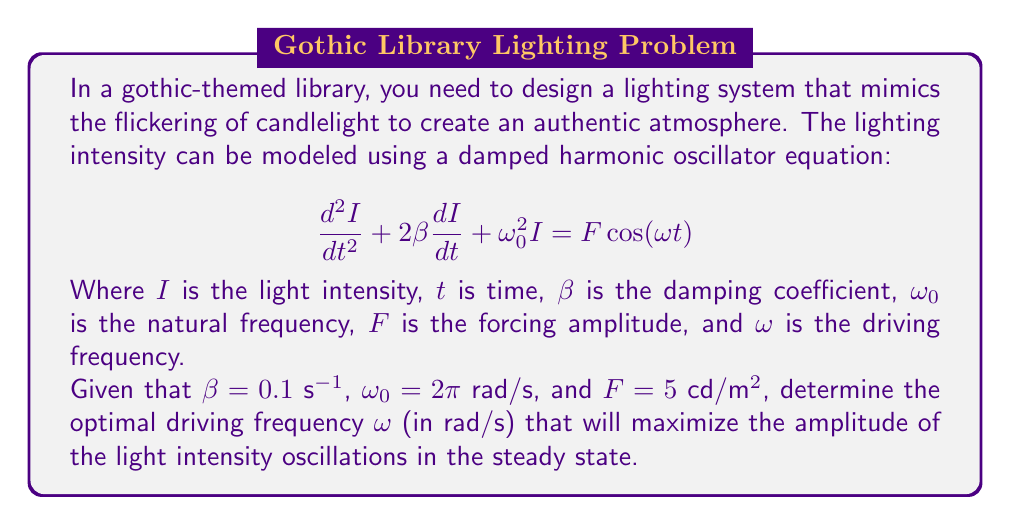Provide a solution to this math problem. To solve this problem, we need to understand the concept of resonance in forced damped harmonic oscillators. The amplitude of oscillations in the steady state is given by the equation:

$$A(\omega) = \frac{F}{\sqrt{(\omega_0^2 - \omega^2)^2 + 4\beta^2\omega^2}}$$

To find the maximum amplitude, we need to find the frequency $\omega$ that minimizes the denominator. We can do this by differentiating the denominator with respect to $\omega$ and setting it to zero:

$$\frac{d}{d\omega}[(\omega_0^2 - \omega^2)^2 + 4\beta^2\omega^2] = 0$$

Simplifying:

$$-4\omega(\omega_0^2 - \omega^2) + 8\beta^2\omega = 0$$

Factoring out $4\omega$:

$$4\omega(-\omega_0^2 + \omega^2 + 2\beta^2) = 0$$

The solution $\omega = 0$ doesn't give a maximum, so we solve:

$$-\omega_0^2 + \omega^2 + 2\beta^2 = 0$$

$$\omega^2 = \omega_0^2 - 2\beta^2$$

Taking the square root of both sides:

$$\omega = \sqrt{\omega_0^2 - 2\beta^2}$$

Now we can substitute the given values:

$$\omega = \sqrt{(2\pi)^2 - 2(0.1)^2}$$

$$\omega = \sqrt{39.4784 - 0.02}$$

$$\omega = \sqrt{39.4584}$$

$$\omega \approx 6.2814$$ rad/s
Answer: The optimal driving frequency to maximize the amplitude of light intensity oscillations is approximately 6.2814 rad/s. 